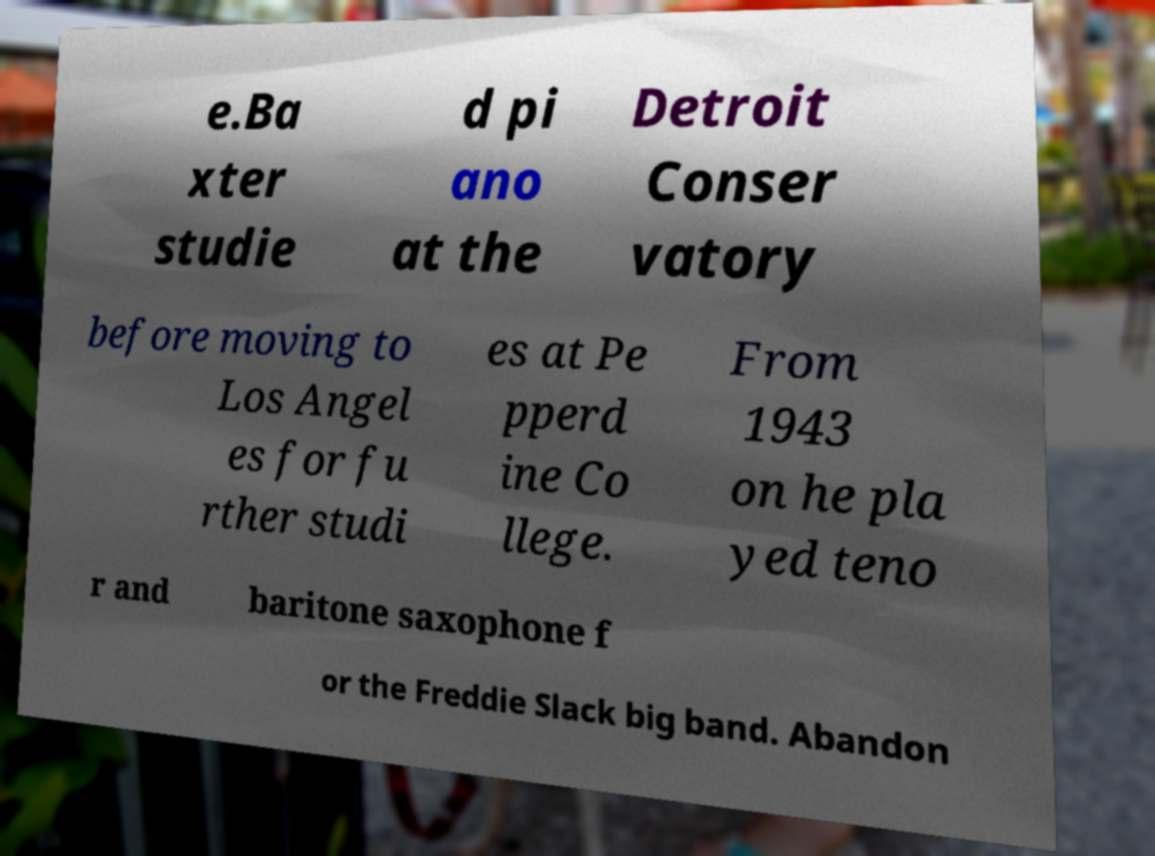Could you extract and type out the text from this image? e.Ba xter studie d pi ano at the Detroit Conser vatory before moving to Los Angel es for fu rther studi es at Pe pperd ine Co llege. From 1943 on he pla yed teno r and baritone saxophone f or the Freddie Slack big band. Abandon 